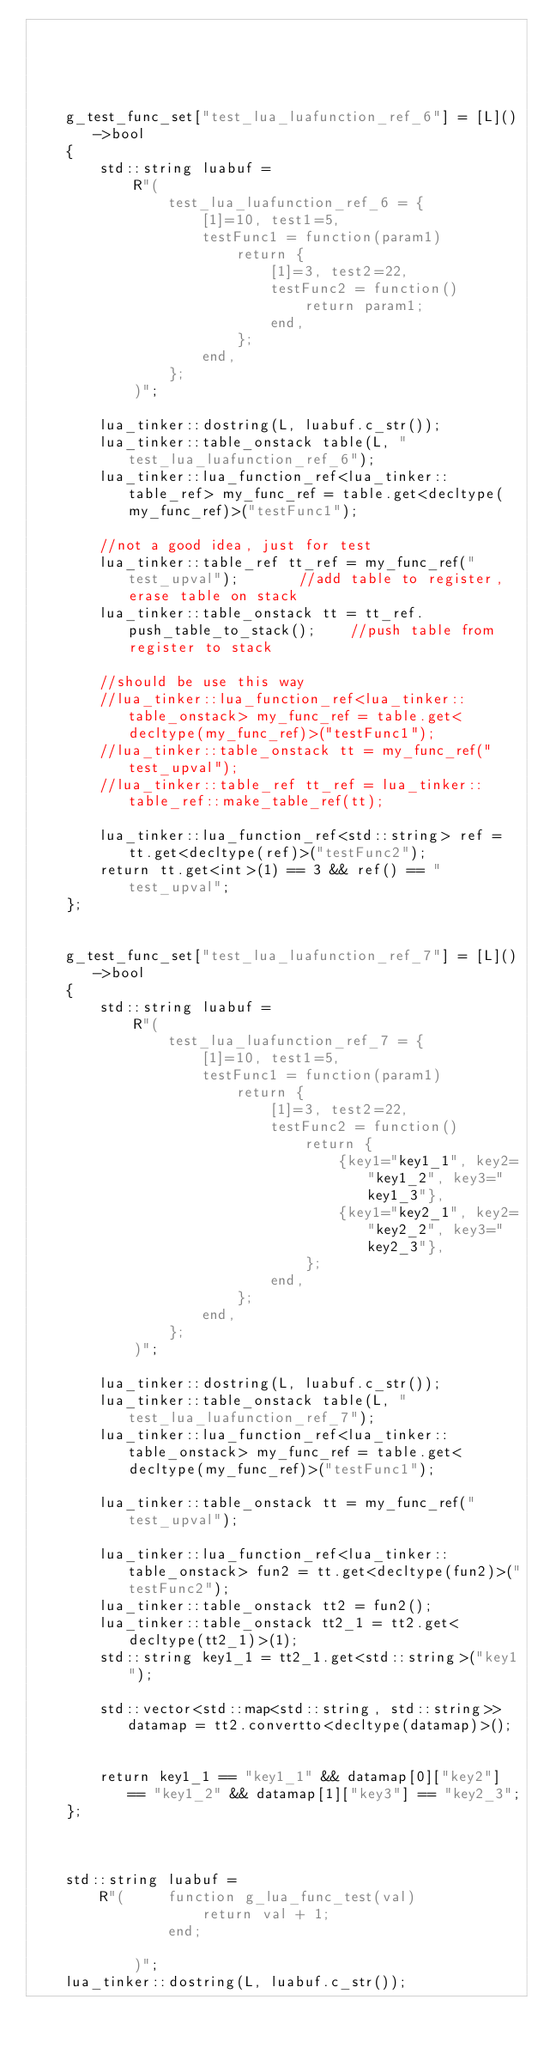Convert code to text. <code><loc_0><loc_0><loc_500><loc_500><_C++_>


		

	g_test_func_set["test_lua_luafunction_ref_6"] = [L]()->bool
	{
		std::string luabuf =
			R"(
				test_lua_luafunction_ref_6 = {
					[1]=10, test1=5,
					testFunc1 = function(param1)
						return {
							[1]=3, test2=22,
							testFunc2 = function()
								return param1;
							end,
						};
					end,
				};
			)";

		lua_tinker::dostring(L, luabuf.c_str());
		lua_tinker::table_onstack table(L, "test_lua_luafunction_ref_6");
		lua_tinker::lua_function_ref<lua_tinker::table_ref> my_func_ref = table.get<decltype(my_func_ref)>("testFunc1");

		//not a good idea, just for test
		lua_tinker::table_ref tt_ref = my_func_ref("test_upval");		//add table to register, erase table on stack
		lua_tinker::table_onstack tt = tt_ref.push_table_to_stack();	//push table from register to stack

		//should be use this way
		//lua_tinker::lua_function_ref<lua_tinker::table_onstack> my_func_ref = table.get<decltype(my_func_ref)>("testFunc1");
		//lua_tinker::table_onstack tt = my_func_ref("test_upval");
		//lua_tinker::table_ref tt_ref = lua_tinker::table_ref::make_table_ref(tt);

		lua_tinker::lua_function_ref<std::string> ref = tt.get<decltype(ref)>("testFunc2");
		return tt.get<int>(1) == 3 && ref() == "test_upval";
	};


	g_test_func_set["test_lua_luafunction_ref_7"] = [L]()->bool
	{
		std::string luabuf =
			R"(
				test_lua_luafunction_ref_7 = {
					[1]=10, test1=5,
					testFunc1 = function(param1)
						return {
							[1]=3, test2=22,
							testFunc2 = function()
								return {
									{key1="key1_1", key2="key1_2", key3="key1_3"},
									{key1="key2_1", key2="key2_2", key3="key2_3"},
								};
							end,
						};
					end,
				};
			)";

		lua_tinker::dostring(L, luabuf.c_str());
		lua_tinker::table_onstack table(L, "test_lua_luafunction_ref_7");
		lua_tinker::lua_function_ref<lua_tinker::table_onstack> my_func_ref = table.get<decltype(my_func_ref)>("testFunc1");

		lua_tinker::table_onstack tt = my_func_ref("test_upval");

		lua_tinker::lua_function_ref<lua_tinker::table_onstack> fun2 = tt.get<decltype(fun2)>("testFunc2");
		lua_tinker::table_onstack tt2 = fun2();
		lua_tinker::table_onstack tt2_1 = tt2.get<decltype(tt2_1)>(1);
		std::string key1_1 = tt2_1.get<std::string>("key1");

		std::vector<std::map<std::string, std::string>> datamap = tt2.convertto<decltype(datamap)>();
		

		return key1_1 == "key1_1" && datamap[0]["key2"] == "key1_2" && datamap[1]["key3"] == "key2_3";
	};



	std::string luabuf =
		R"( 	function g_lua_func_test(val)
					return val + 1;
				end;
				
			)";
	lua_tinker::dostring(L, luabuf.c_str());</code> 